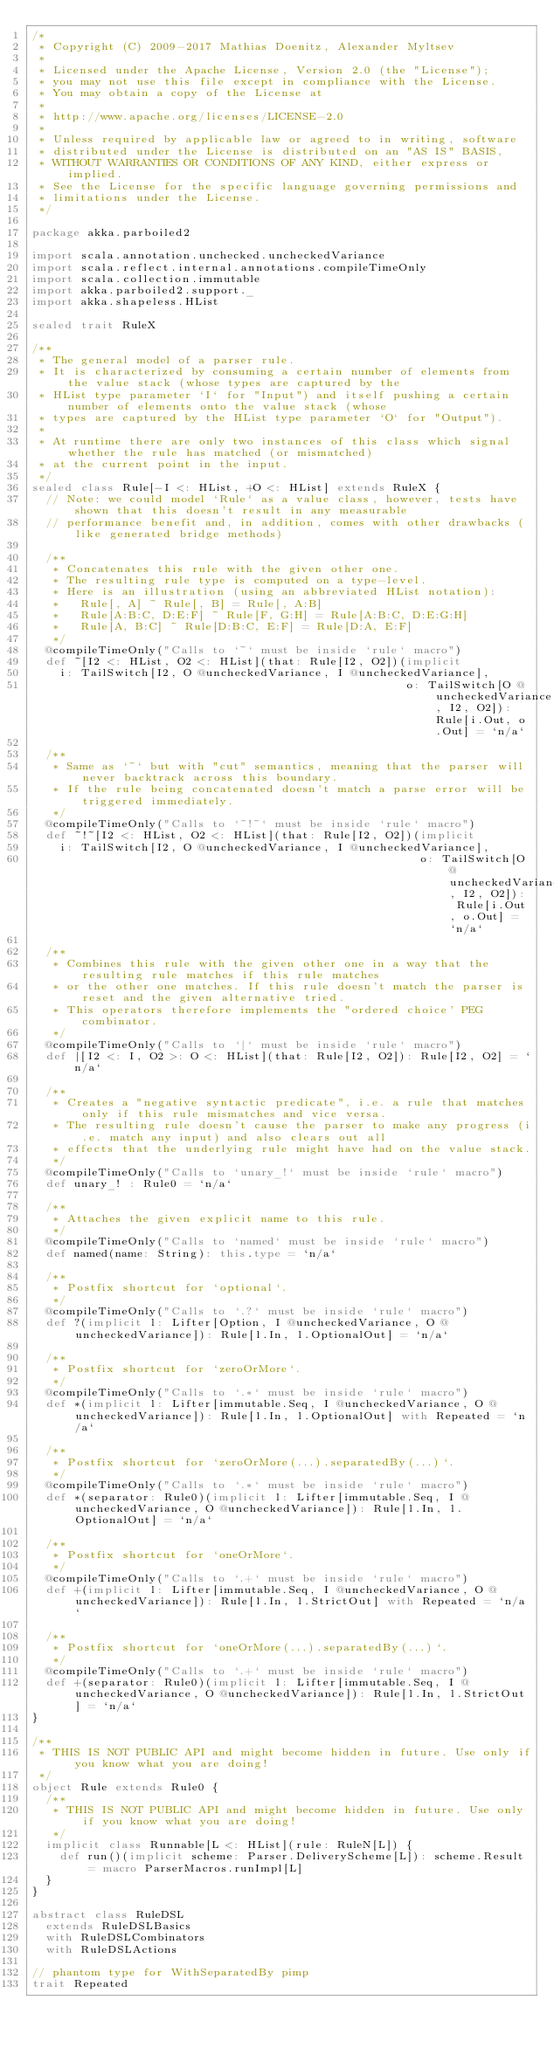Convert code to text. <code><loc_0><loc_0><loc_500><loc_500><_Scala_>/*
 * Copyright (C) 2009-2017 Mathias Doenitz, Alexander Myltsev
 *
 * Licensed under the Apache License, Version 2.0 (the "License");
 * you may not use this file except in compliance with the License.
 * You may obtain a copy of the License at
 *
 * http://www.apache.org/licenses/LICENSE-2.0
 *
 * Unless required by applicable law or agreed to in writing, software
 * distributed under the License is distributed on an "AS IS" BASIS,
 * WITHOUT WARRANTIES OR CONDITIONS OF ANY KIND, either express or implied.
 * See the License for the specific language governing permissions and
 * limitations under the License.
 */

package akka.parboiled2

import scala.annotation.unchecked.uncheckedVariance
import scala.reflect.internal.annotations.compileTimeOnly
import scala.collection.immutable
import akka.parboiled2.support._
import akka.shapeless.HList

sealed trait RuleX

/**
 * The general model of a parser rule.
 * It is characterized by consuming a certain number of elements from the value stack (whose types are captured by the
 * HList type parameter `I` for "Input") and itself pushing a certain number of elements onto the value stack (whose
 * types are captured by the HList type parameter `O` for "Output").
 *
 * At runtime there are only two instances of this class which signal whether the rule has matched (or mismatched)
 * at the current point in the input.
 */
sealed class Rule[-I <: HList, +O <: HList] extends RuleX {
  // Note: we could model `Rule` as a value class, however, tests have shown that this doesn't result in any measurable
  // performance benefit and, in addition, comes with other drawbacks (like generated bridge methods)

  /**
   * Concatenates this rule with the given other one.
   * The resulting rule type is computed on a type-level.
   * Here is an illustration (using an abbreviated HList notation):
   *   Rule[, A] ~ Rule[, B] = Rule[, A:B]
   *   Rule[A:B:C, D:E:F] ~ Rule[F, G:H] = Rule[A:B:C, D:E:G:H]
   *   Rule[A, B:C] ~ Rule[D:B:C, E:F] = Rule[D:A, E:F]
   */
  @compileTimeOnly("Calls to `~` must be inside `rule` macro")
  def ~[I2 <: HList, O2 <: HList](that: Rule[I2, O2])(implicit
    i: TailSwitch[I2, O @uncheckedVariance, I @uncheckedVariance],
                                                      o: TailSwitch[O @uncheckedVariance, I2, O2]): Rule[i.Out, o.Out] = `n/a`

  /**
   * Same as `~` but with "cut" semantics, meaning that the parser will never backtrack across this boundary.
   * If the rule being concatenated doesn't match a parse error will be triggered immediately.
   */
  @compileTimeOnly("Calls to `~!~` must be inside `rule` macro")
  def ~!~[I2 <: HList, O2 <: HList](that: Rule[I2, O2])(implicit
    i: TailSwitch[I2, O @uncheckedVariance, I @uncheckedVariance],
                                                        o: TailSwitch[O @uncheckedVariance, I2, O2]): Rule[i.Out, o.Out] = `n/a`

  /**
   * Combines this rule with the given other one in a way that the resulting rule matches if this rule matches
   * or the other one matches. If this rule doesn't match the parser is reset and the given alternative tried.
   * This operators therefore implements the "ordered choice' PEG combinator.
   */
  @compileTimeOnly("Calls to `|` must be inside `rule` macro")
  def |[I2 <: I, O2 >: O <: HList](that: Rule[I2, O2]): Rule[I2, O2] = `n/a`

  /**
   * Creates a "negative syntactic predicate", i.e. a rule that matches only if this rule mismatches and vice versa.
   * The resulting rule doesn't cause the parser to make any progress (i.e. match any input) and also clears out all
   * effects that the underlying rule might have had on the value stack.
   */
  @compileTimeOnly("Calls to `unary_!` must be inside `rule` macro")
  def unary_! : Rule0 = `n/a`

  /**
   * Attaches the given explicit name to this rule.
   */
  @compileTimeOnly("Calls to `named` must be inside `rule` macro")
  def named(name: String): this.type = `n/a`

  /**
   * Postfix shortcut for `optional`.
   */
  @compileTimeOnly("Calls to `.?` must be inside `rule` macro")
  def ?(implicit l: Lifter[Option, I @uncheckedVariance, O @uncheckedVariance]): Rule[l.In, l.OptionalOut] = `n/a`

  /**
   * Postfix shortcut for `zeroOrMore`.
   */
  @compileTimeOnly("Calls to `.*` must be inside `rule` macro")
  def *(implicit l: Lifter[immutable.Seq, I @uncheckedVariance, O @uncheckedVariance]): Rule[l.In, l.OptionalOut] with Repeated = `n/a`

  /**
   * Postfix shortcut for `zeroOrMore(...).separatedBy(...)`.
   */
  @compileTimeOnly("Calls to `.*` must be inside `rule` macro")
  def *(separator: Rule0)(implicit l: Lifter[immutable.Seq, I @uncheckedVariance, O @uncheckedVariance]): Rule[l.In, l.OptionalOut] = `n/a`

  /**
   * Postfix shortcut for `oneOrMore`.
   */
  @compileTimeOnly("Calls to `.+` must be inside `rule` macro")
  def +(implicit l: Lifter[immutable.Seq, I @uncheckedVariance, O @uncheckedVariance]): Rule[l.In, l.StrictOut] with Repeated = `n/a`

  /**
   * Postfix shortcut for `oneOrMore(...).separatedBy(...)`.
   */
  @compileTimeOnly("Calls to `.+` must be inside `rule` macro")
  def +(separator: Rule0)(implicit l: Lifter[immutable.Seq, I @uncheckedVariance, O @uncheckedVariance]): Rule[l.In, l.StrictOut] = `n/a`
}

/**
 * THIS IS NOT PUBLIC API and might become hidden in future. Use only if you know what you are doing!
 */
object Rule extends Rule0 {
  /**
   * THIS IS NOT PUBLIC API and might become hidden in future. Use only if you know what you are doing!
   */
  implicit class Runnable[L <: HList](rule: RuleN[L]) {
    def run()(implicit scheme: Parser.DeliveryScheme[L]): scheme.Result = macro ParserMacros.runImpl[L]
  }
}

abstract class RuleDSL
  extends RuleDSLBasics
  with RuleDSLCombinators
  with RuleDSLActions

// phantom type for WithSeparatedBy pimp
trait Repeated
</code> 